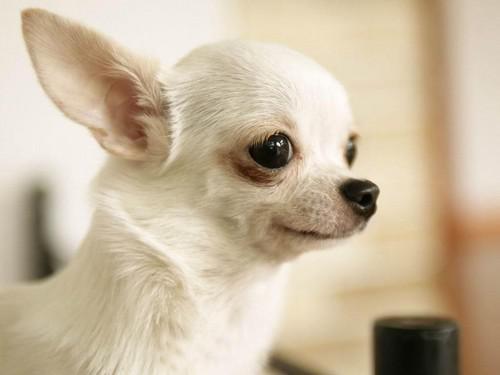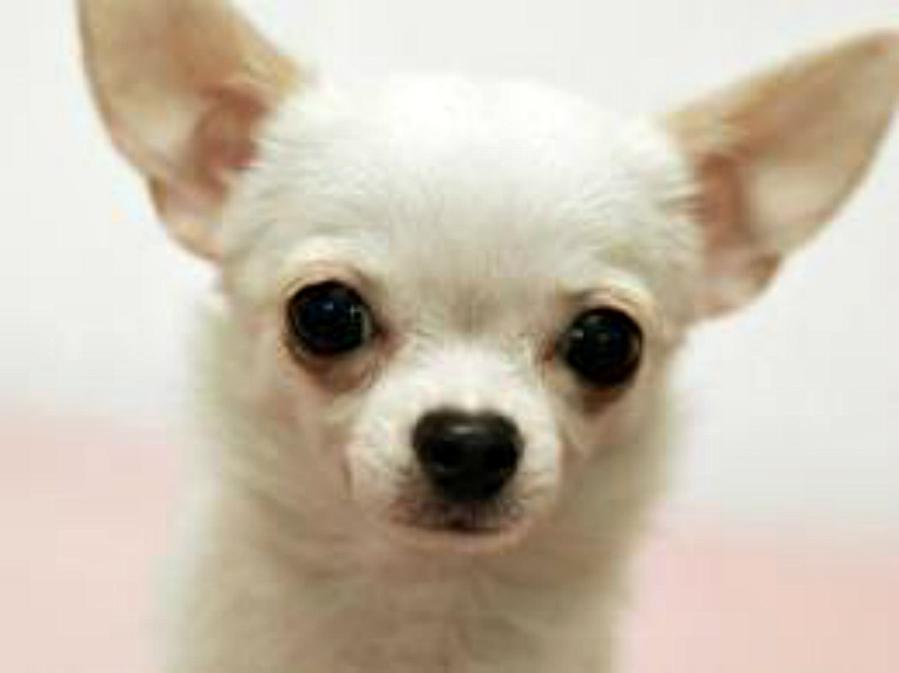The first image is the image on the left, the second image is the image on the right. For the images shown, is this caption "At least one of the dogs is wearing a collar." true? Answer yes or no. No. The first image is the image on the left, the second image is the image on the right. Considering the images on both sides, is "Each image includes a white chihuahua, and the one in the right image faces forward with erect ears." valid? Answer yes or no. Yes. 